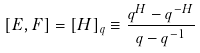Convert formula to latex. <formula><loc_0><loc_0><loc_500><loc_500>[ E , F ] = [ H ] _ { q } \equiv \frac { q ^ { H } - q ^ { - H } } { q - q ^ { - 1 } }</formula> 